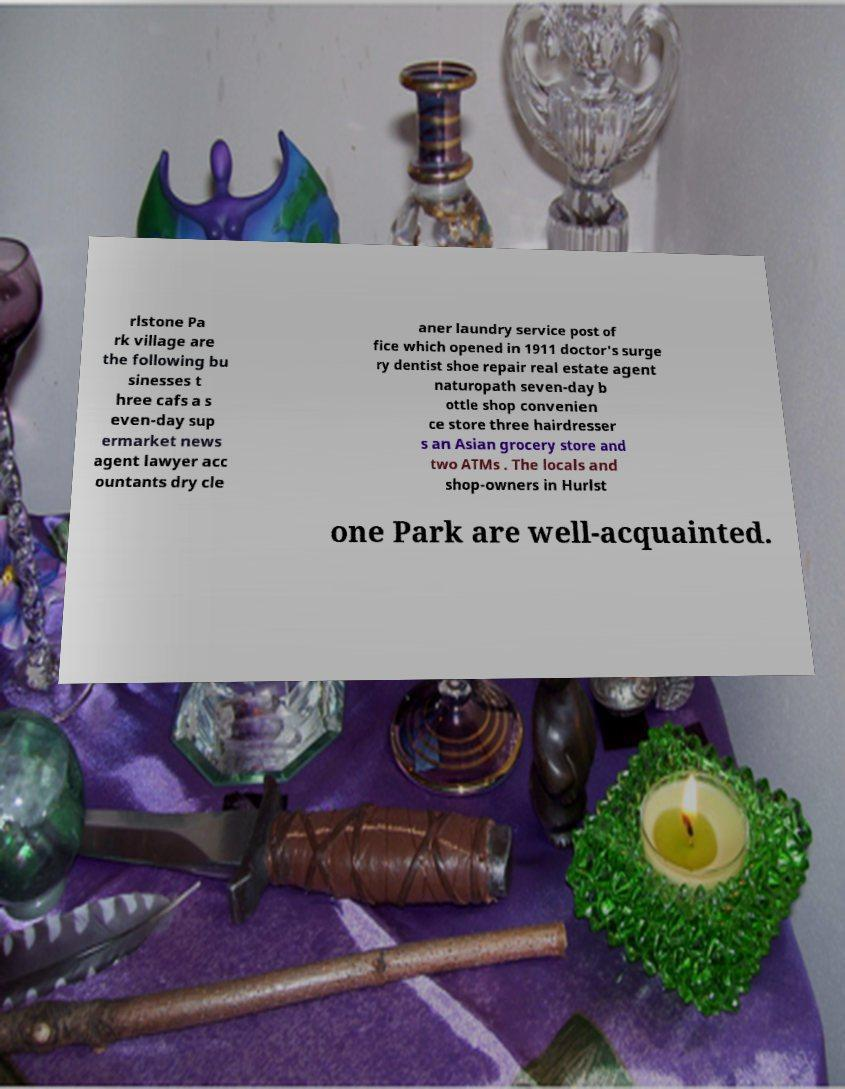Could you assist in decoding the text presented in this image and type it out clearly? rlstone Pa rk village are the following bu sinesses t hree cafs a s even-day sup ermarket news agent lawyer acc ountants dry cle aner laundry service post of fice which opened in 1911 doctor's surge ry dentist shoe repair real estate agent naturopath seven-day b ottle shop convenien ce store three hairdresser s an Asian grocery store and two ATMs . The locals and shop-owners in Hurlst one Park are well-acquainted. 